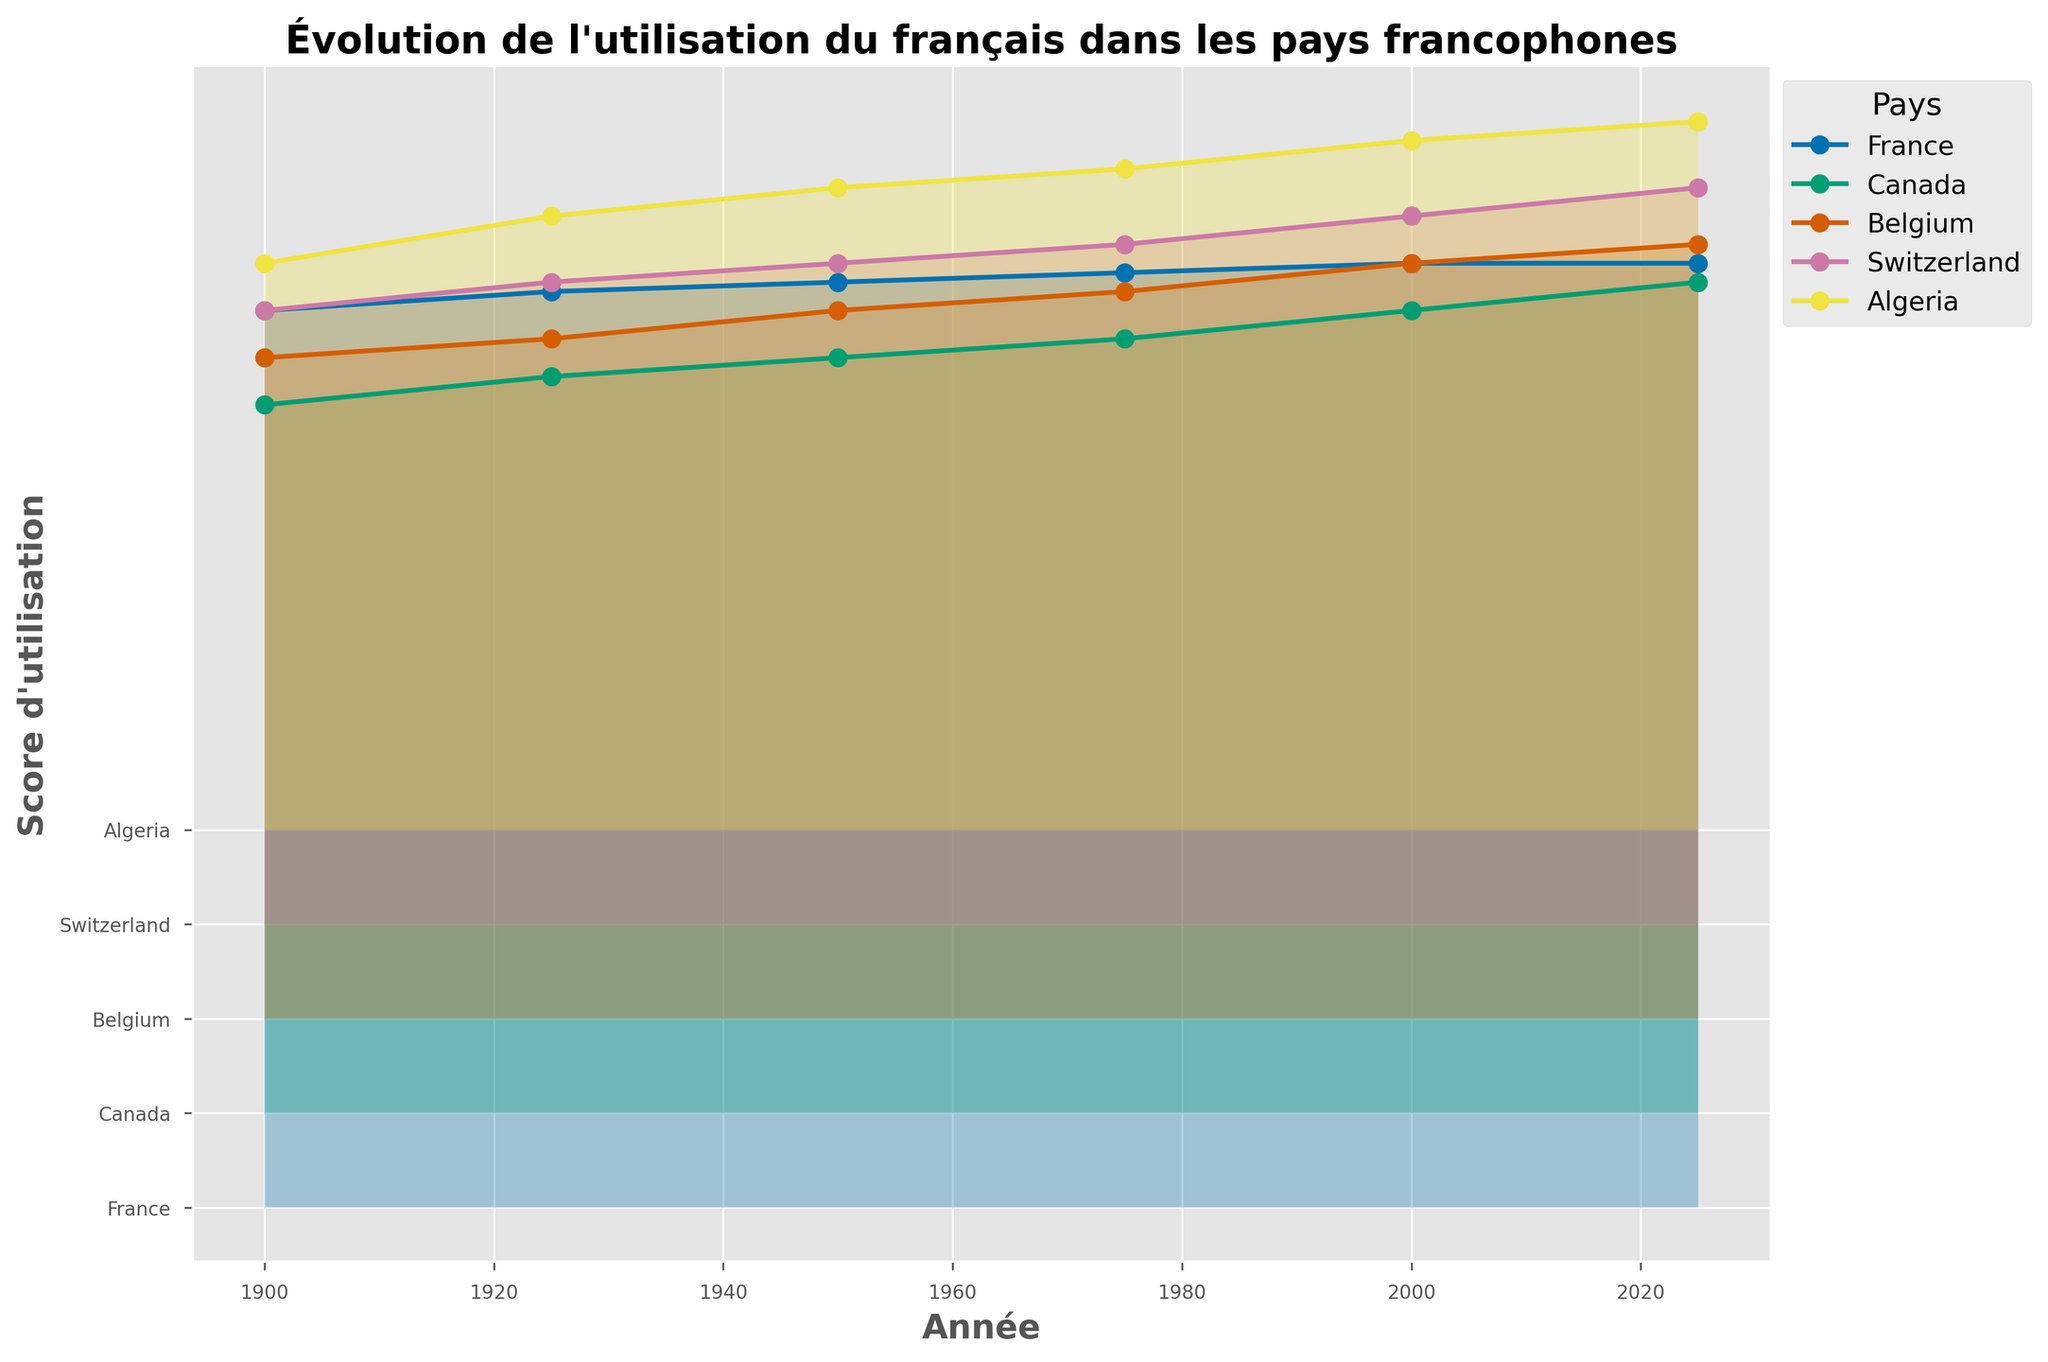How many countries are displayed on the plot? The plot shows ridgeline plots for each country, with separate lines for each country. By counting the number of different lines, you can see there are five countries.
Answer: Five Which country shows a consistent increase in usage score from 1900 to 2025? By examining the trend lines for each country, France shows a consistent increase in usage score from 95 in 1900 to 100 in 2025.
Answer: France What is the score difference between France and Algeria in 1925? France has a score of 97, and Algeria has a score of 65 in 1925. The difference is 97 - 65.
Answer: 32 Which country has the lowest usage score in the year 2000? Review the vertical position of the scores for each country in the year 2000; Switzerland is at the lowest point with a usage score of 75.
Answer: Switzerland Which two countries have similar usage scores in 1900? Comparing the scores in 1900, Belgium (70) and Switzerland (65) have close usage scores.
Answer: Belgium and Switzerland How much did Canada's usage score improve between 1975 and 2000? Canada's score in 1975 is 82 and in 2000 is 85. The improvement is 85 - 82.
Answer: 3 Which country shows the smallest change in usage score from 1900 to 2025? Checking the beginning and end scores of each country, France started at 95 and ended at 100, showing a small increase of 5 points.
Answer: France By how much did Belgium's usage score change from 1950 to 1975? Belgium's score changed from 75 in 1950 to 77 in 1975, a difference of 77 - 75.
Answer: 2 Between 1950 and 2025, which country shows the most improvement in usage score? Comparing the increase in scores from 1950 to 2025, Algeria's score improved from 68 to 75, an increase of 7 points. Canada improved more from 80 to 88, a change of 8 points.
Answer: Canada Which country has the highest score in 2025? The plot shows the highest score in 2025 is for France at 100.
Answer: France 